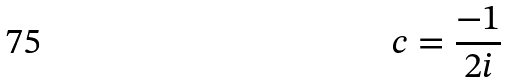<formula> <loc_0><loc_0><loc_500><loc_500>c = \frac { - 1 } { 2 i }</formula> 